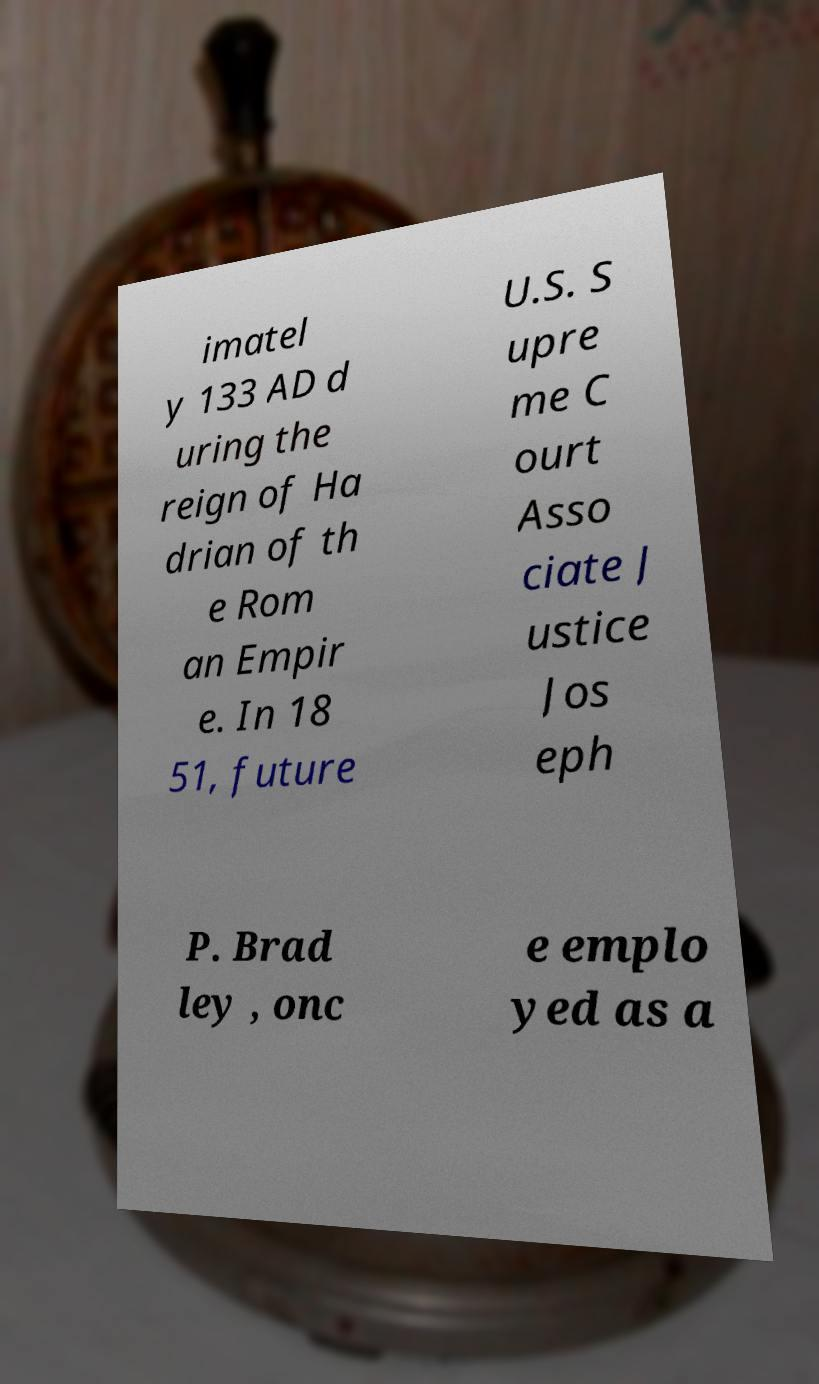Could you assist in decoding the text presented in this image and type it out clearly? imatel y 133 AD d uring the reign of Ha drian of th e Rom an Empir e. In 18 51, future U.S. S upre me C ourt Asso ciate J ustice Jos eph P. Brad ley , onc e emplo yed as a 